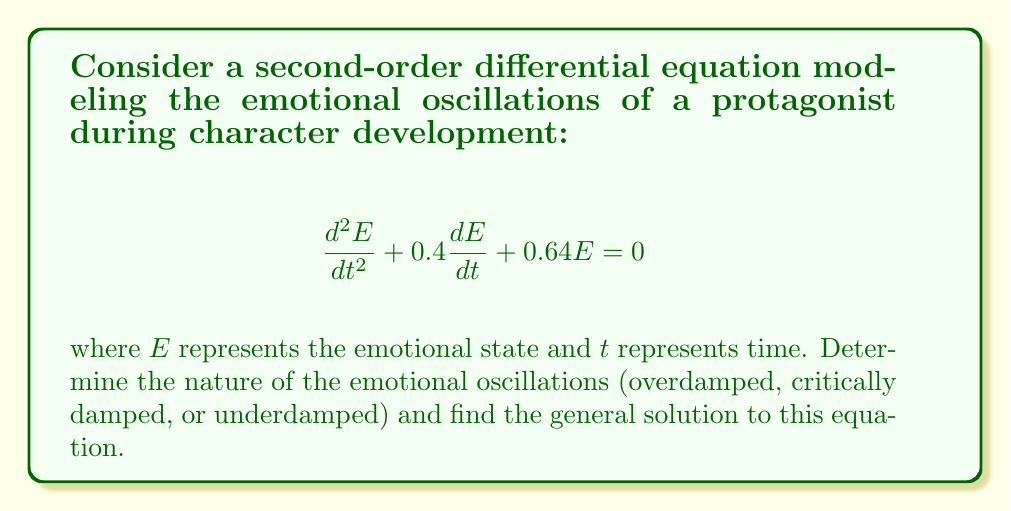Help me with this question. 1) First, we identify this as a homogeneous second-order linear differential equation in the form:
   $$\frac{d^2E}{dt^2} + 2\zeta\omega_n\frac{dE}{dt} + \omega_n^2E = 0$$
   where $\zeta$ is the damping ratio and $\omega_n$ is the natural frequency.

2) Comparing our equation to this standard form, we see that:
   $2\zeta\omega_n = 0.4$ and $\omega_n^2 = 0.64$

3) We can solve for $\omega_n$:
   $\omega_n = \sqrt{0.64} = 0.8$

4) Then we can find $\zeta$:
   $\zeta = \frac{0.4}{2(0.8)} = 0.25$

5) Since $0 < \zeta < 1$, the system is underdamped, meaning the emotional state will oscillate with decreasing amplitude.

6) For an underdamped system, the general solution is:
   $$E(t) = e^{-\zeta\omega_n t}(C_1\cos(\omega_d t) + C_2\sin(\omega_d t))$$
   where $\omega_d = \omega_n\sqrt{1-\zeta^2}$ is the damped natural frequency.

7) Calculate $\omega_d$:
   $\omega_d = 0.8\sqrt{1-0.25^2} \approx 0.7746$

8) Therefore, the general solution is:
   $$E(t) = e^{-0.2t}(C_1\cos(0.7746t) + C_2\sin(0.7746t))$$
   where $C_1$ and $C_2$ are constants determined by initial conditions.
Answer: Underdamped; $E(t) = e^{-0.2t}(C_1\cos(0.7746t) + C_2\sin(0.7746t))$ 